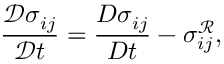<formula> <loc_0><loc_0><loc_500><loc_500>\frac { \mathcal { D } \sigma _ { i j } } { \mathcal { D } t } = \frac { { D } \sigma _ { i j } } { { D } t } - { \sigma _ { i j } ^ { \mathcal { R } } } ,</formula> 